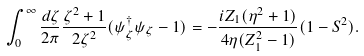Convert formula to latex. <formula><loc_0><loc_0><loc_500><loc_500>\int _ { 0 } ^ { \infty } \frac { d \zeta } { 2 \pi } \frac { \zeta ^ { 2 } + 1 } { 2 \zeta ^ { 2 } } ( \psi _ { \zeta } ^ { \dagger } \psi _ { \zeta } - 1 ) = - \frac { i Z _ { 1 } ( \eta ^ { 2 } + 1 ) } { 4 \eta ( Z _ { 1 } ^ { 2 } - 1 ) } ( 1 - S ^ { 2 } ) .</formula> 